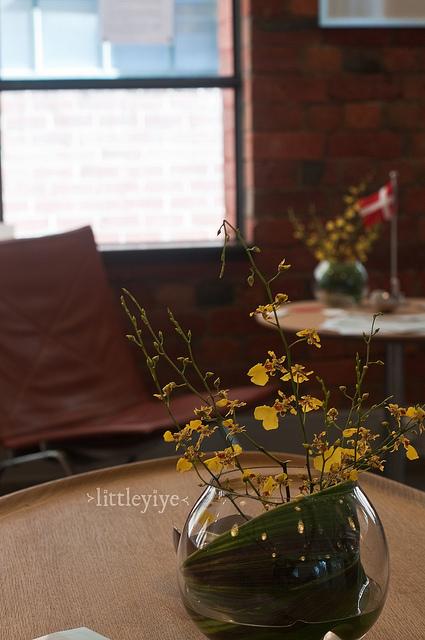What number of flowers are in this glass bowl?
Quick response, please. 15. Are the flowers fresh or fake?
Concise answer only. Fresh. Is there a bird on top of the chair?
Give a very brief answer. No. Is the bowl made of glass?
Concise answer only. Yes. What type of flower is in the bowl?
Write a very short answer. Wild. Does this room look messy?
Answer briefly. No. What has light in the photo?
Concise answer only. Window. Is this a cafe?
Write a very short answer. Yes. Are the flowers real or artificial?
Concise answer only. Real. 